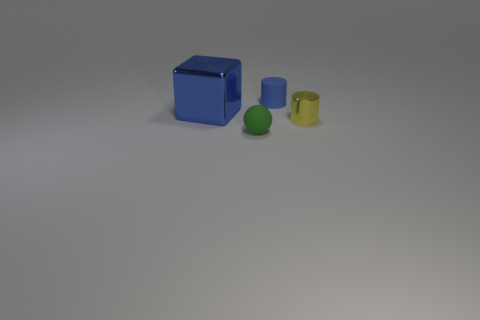Add 2 red metal spheres. How many objects exist? 6 Subtract all blocks. How many objects are left? 3 Subtract 0 blue balls. How many objects are left? 4 Subtract all red metallic cylinders. Subtract all large blue metallic objects. How many objects are left? 3 Add 4 green matte objects. How many green matte objects are left? 5 Add 3 brown cylinders. How many brown cylinders exist? 3 